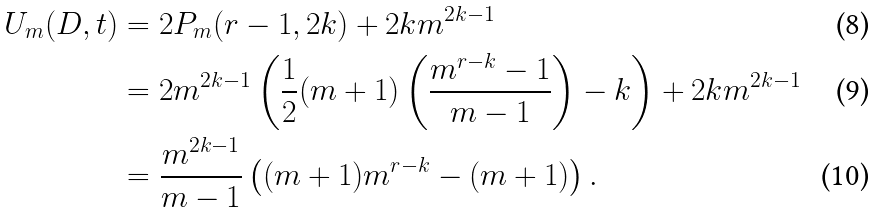<formula> <loc_0><loc_0><loc_500><loc_500>U _ { m } ( D , t ) & = 2 P _ { m } ( r - 1 , 2 k ) + 2 k m ^ { 2 k - 1 } \\ & = 2 m ^ { 2 k - 1 } \left ( \frac { 1 } { 2 } ( m + 1 ) \left ( \frac { m ^ { r - k } - 1 } { m - 1 } \right ) - k \right ) + 2 k m ^ { 2 k - 1 } \\ & = \frac { m ^ { 2 k - 1 } } { m - 1 } \left ( ( m + 1 ) m ^ { r - k } - ( m + 1 ) \right ) .</formula> 